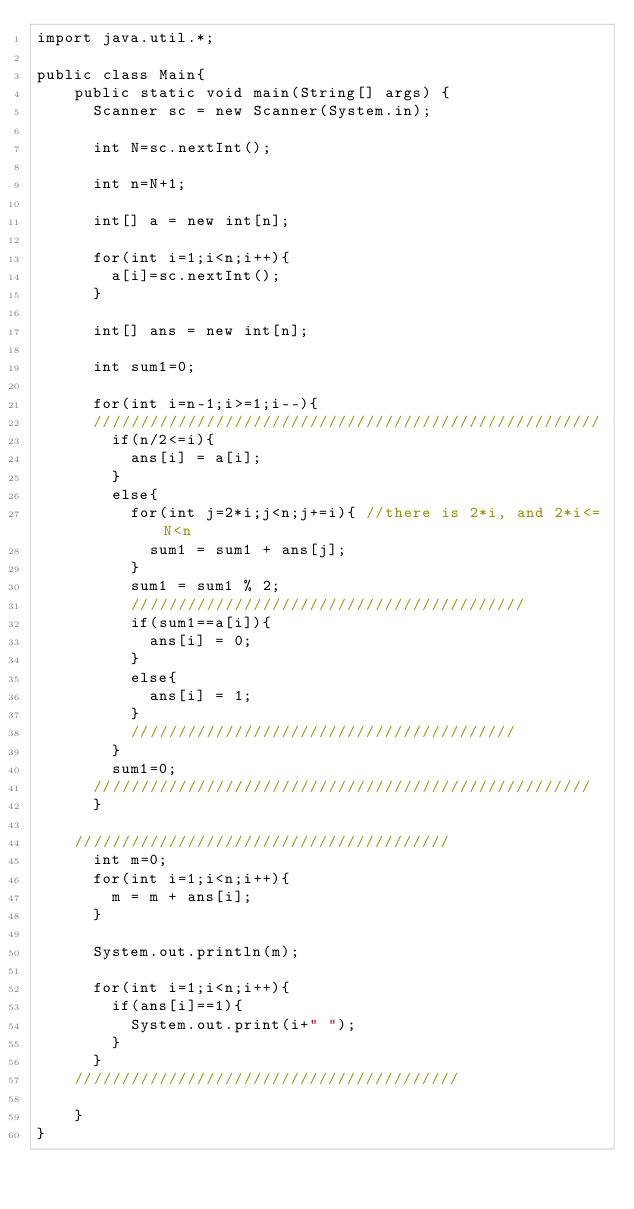Convert code to text. <code><loc_0><loc_0><loc_500><loc_500><_Java_>import java.util.*;

public class Main{
    public static void main(String[] args) {
      Scanner sc = new Scanner(System.in);

      int N=sc.nextInt();

      int n=N+1;

      int[] a = new int[n];

      for(int i=1;i<n;i++){
        a[i]=sc.nextInt();
      }

      int[] ans = new int[n];

      int sum1=0;

      for(int i=n-1;i>=1;i--){
      //////////////////////////////////////////////////////
        if(n/2<=i){
          ans[i] = a[i];
        }
        else{
          for(int j=2*i;j<n;j+=i){ //there is 2*i, and 2*i<=N<n
            sum1 = sum1 + ans[j];
          }
          sum1 = sum1 % 2;
          //////////////////////////////////////////
          if(sum1==a[i]){
            ans[i] = 0;
          }
          else{
            ans[i] = 1;
          }
          /////////////////////////////////////////
        }
        sum1=0;
      /////////////////////////////////////////////////////
      }

    ////////////////////////////////////////
      int m=0;
      for(int i=1;i<n;i++){
        m = m + ans[i];
      }

      System.out.println(m);

      for(int i=1;i<n;i++){
        if(ans[i]==1){
          System.out.print(i+" ");
        }
      }
    /////////////////////////////////////////

    }
}
</code> 